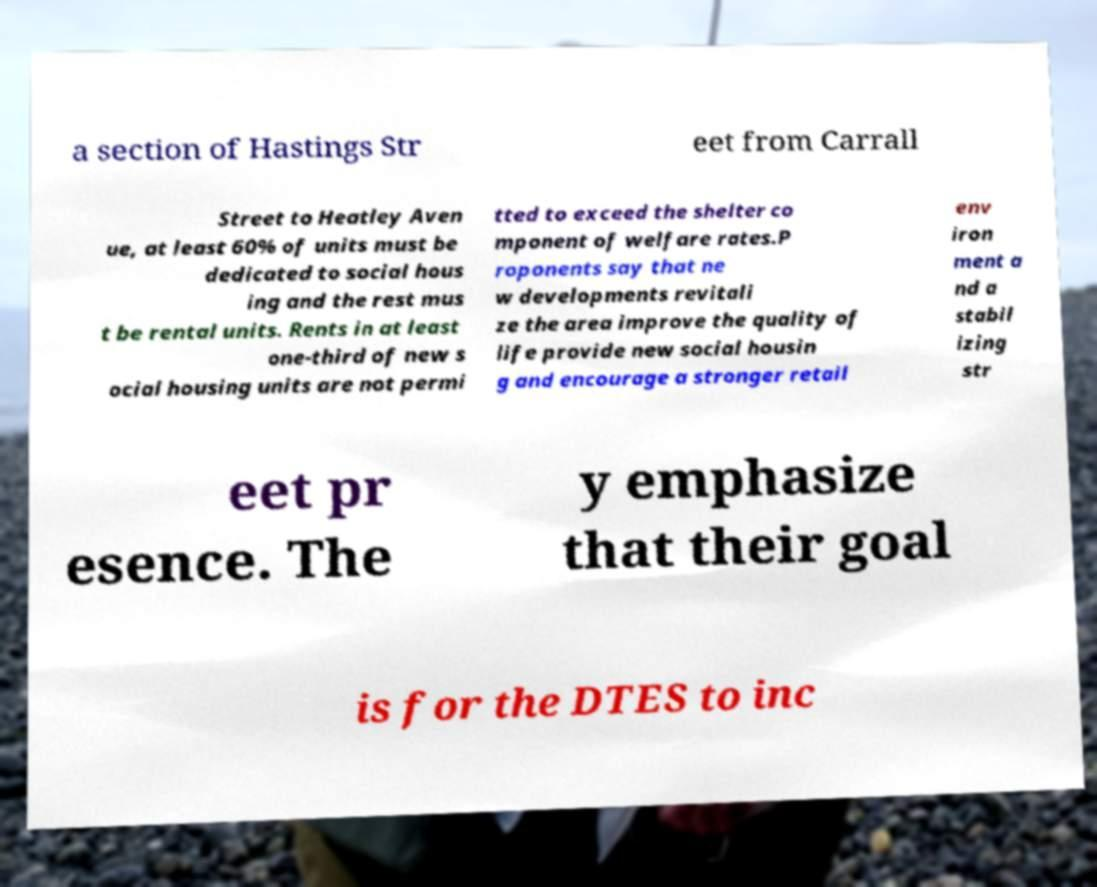Can you read and provide the text displayed in the image?This photo seems to have some interesting text. Can you extract and type it out for me? a section of Hastings Str eet from Carrall Street to Heatley Aven ue, at least 60% of units must be dedicated to social hous ing and the rest mus t be rental units. Rents in at least one-third of new s ocial housing units are not permi tted to exceed the shelter co mponent of welfare rates.P roponents say that ne w developments revitali ze the area improve the quality of life provide new social housin g and encourage a stronger retail env iron ment a nd a stabil izing str eet pr esence. The y emphasize that their goal is for the DTES to inc 